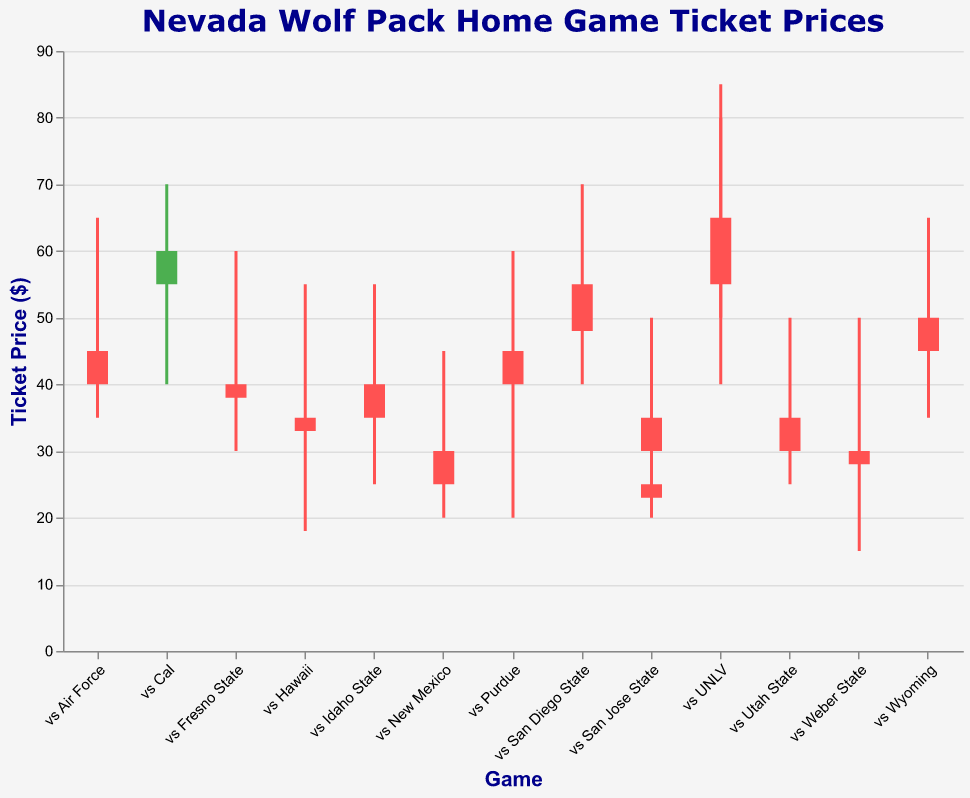What is the highest ticket price for the game against Hawaii in 2019? Locate the candlestick corresponding to the game "vs Hawaii" in the 2019 season and find the highest value on the vertical axis, which represents ticket prices. The High value for this game is 55.
Answer: 55 How many games had a closing price lower than the opening price? Examine each candlestick to determine whether the closing price (top of the bar) is lower than the opening price (bottom of the bar). Count these instances. There are 11 such games.
Answer: 11 What is the average closing price for home games in the 2020 season? Identify the candlesticks for the 2020 season and sum their closing prices (45, 48, 38, 25, 30). Then, divide by the number of games (5). The average is (45 + 48 + 38 + 25 + 30) / 5 = 186 / 5 = 37.2
Answer: 37.2 Which game had the smallest range between the high and low prices? Examine the difference between the high and low prices for each game. The smallest difference is found in the game "vs San Jose State" in 2019, where the difference is (40 - 20) = 20.
Answer: "vs San Jose State" in 2019 Which game had the greatest increase in ticket price from open to close? Calculate the difference between the closing and opening prices for each game. The game with the largest increase is "vs Cal" in 2021, with an increase of (60 - 55) = 5.
Answer: "vs Cal" in 2021 How many games had a high price above $70? Count the number of candlesticks where the high value exceeds 70. There are 3 such games: "vs UNLV" in 2019, "vs UNLV" in 2021, and "vs Cal" in 2021.
Answer: 3 What was the lowest ticket price recorded for any game in the 2021 season? Examine the low values for each game in the 2021 season and find the minimum. The lowest low value is 25.
Answer: 25 Compare the ticket price range for the games against UNLV in 2019 and 2021. Which season had a higher range? Calculate the range (High - Low) for both games. In 2019, the range is (80 - 40) = 40. In 2021, the range is (85 - 50) = 35. The 2019 game had a higher range.
Answer: 2019 Which game in the dataset had an opening price equal to the closing price? Identify if any candlestick has the opening price equal to the closing price. No such game exists in the dataset.
Answer: None What is the median opening price for all the games? List all the opening prices and find the median. Sorted opening prices are (25, 30, 30, 35, 35, 40, 40, 45, 45, 50, 55, 55, 60, 65). The median is the average of the two middle values since there are 14 games, which are 40 and 45. Median = (40 + 45) / 2 = 42.5.
Answer: 42.5 